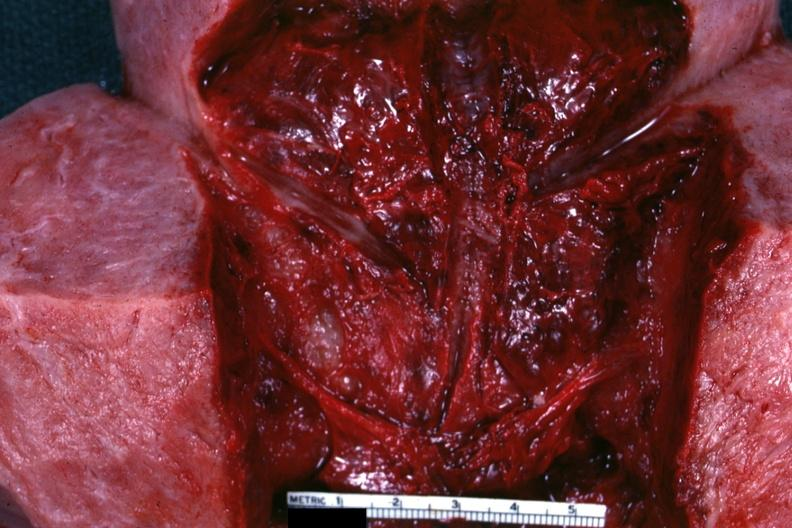what is present?
Answer the question using a single word or phrase. Female reproductive 